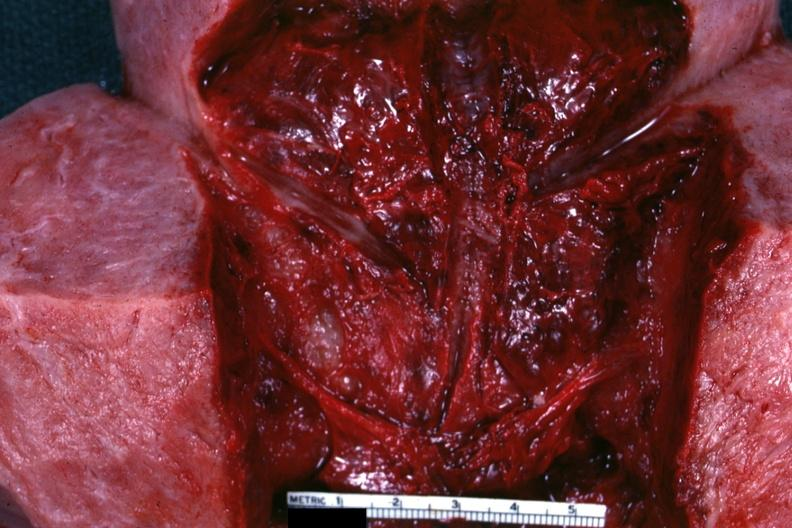what is present?
Answer the question using a single word or phrase. Female reproductive 